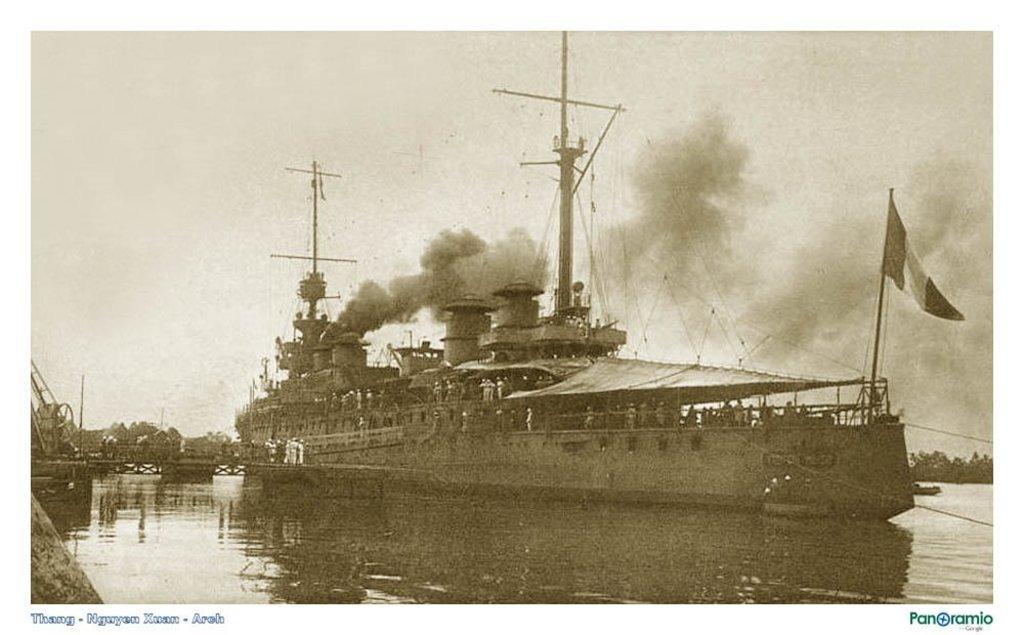Could you give a brief overview of what you see in this image? In this image I can see an old photograph in which I can see the water, a huge ship on the surface of the water, a flag on the ship and a black smoke coming from the ship. In the background I can see few trees, few persons standing on the bridge and the sky. 